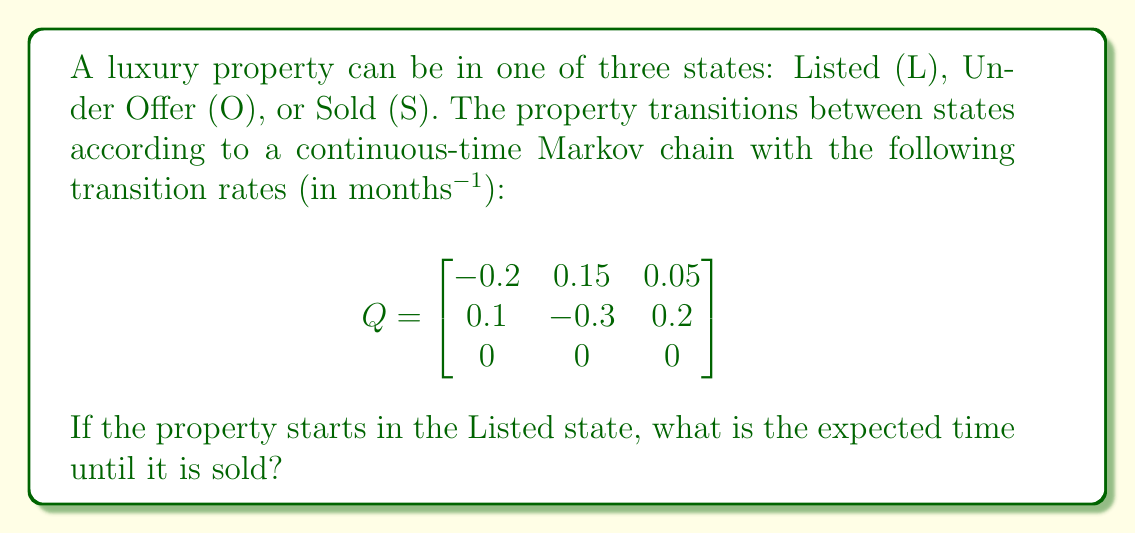Help me with this question. To find the expected time until the property is sold, we need to calculate the mean absorption time starting from the Listed state. We'll follow these steps:

1) First, we need to identify the transient states (L and O) and the absorbing state (S).

2) We extract the submatrix Q' containing only the transition rates between transient states:

   $$ Q' = \begin{bmatrix}
   -0.2 & 0.15 \\
   0.1 & -0.3
   \end{bmatrix} $$

3) The fundamental matrix N is given by $N = -Q'^{-1}$. Let's calculate it:

   $$ N = -\begin{bmatrix}
   -0.2 & 0.15 \\
   0.1 & -0.3
   \end{bmatrix}^{-1} = \frac{1}{0.06 - 0.015}\begin{bmatrix}
   0.3 & 0.15 \\
   0.1 & 0.2
   \end{bmatrix} = \begin{bmatrix}
   6.67 & 3.33 \\
   2.22 & 4.44
   \end{bmatrix} $$

4) The expected time to absorption (selling) from each transient state is given by the sum of the corresponding row in N. We're interested in the first row (Listed state):

   Expected time = 6.67 + 3.33 = 10 months

Therefore, starting from the Listed state, the expected time until the property is sold is 10 months.
Answer: 10 months 